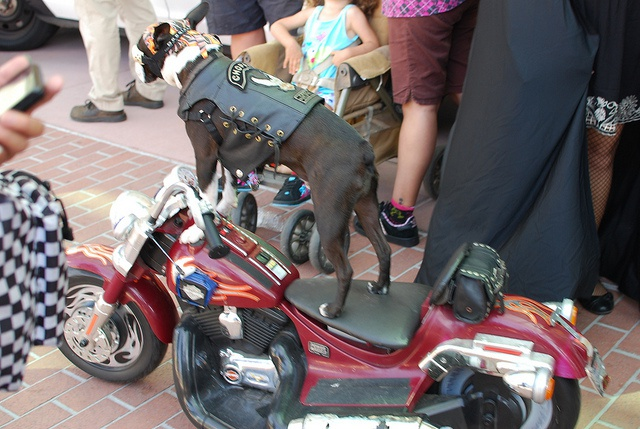Describe the objects in this image and their specific colors. I can see motorcycle in darkgray, gray, black, and white tones, people in darkgray and black tones, dog in darkgray, gray, black, and white tones, people in darkgray, black, maroon, brown, and tan tones, and people in darkgray, lightgray, and gray tones in this image. 